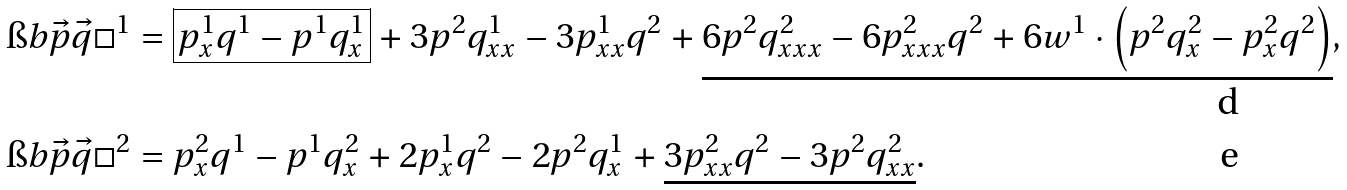Convert formula to latex. <formula><loc_0><loc_0><loc_500><loc_500>\i b { \vec { p } } { \vec { q } } { \square } ^ { 1 } & = \boxed { p ^ { 1 } _ { x } q ^ { 1 } - p ^ { 1 } q ^ { 1 } _ { x } } + 3 p ^ { 2 } q ^ { 1 } _ { x x } - 3 p ^ { 1 } _ { x x } q ^ { 2 } + \underline { 6 p ^ { 2 } q ^ { 2 } _ { x x x } - 6 p ^ { 2 } _ { x x x } q ^ { 2 } + 6 w ^ { 1 } \cdot \left ( p ^ { 2 } q ^ { 2 } _ { x } - p ^ { 2 } _ { x } q ^ { 2 } \right ) } , \\ \i b { \vec { p } } { \vec { q } } { \square } ^ { 2 } & = p ^ { 2 } _ { x } q ^ { 1 } - p ^ { 1 } q ^ { 2 } _ { x } + 2 p ^ { 1 } _ { x } q ^ { 2 } - 2 p ^ { 2 } q ^ { 1 } _ { x } + \underline { 3 p ^ { 2 } _ { x x } q ^ { 2 } - 3 p ^ { 2 } q ^ { 2 } _ { x x } } .</formula> 